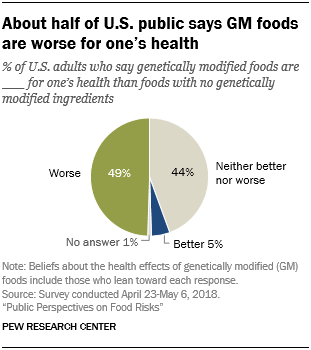Identify some key points in this picture. The pie graph displays that blue color represents 5% of the total information being shown. The difference between worse and neither better nor worse is that worse indicates a significant decline in quality or performance, while neither better nor worse indicates no change or little difference. 